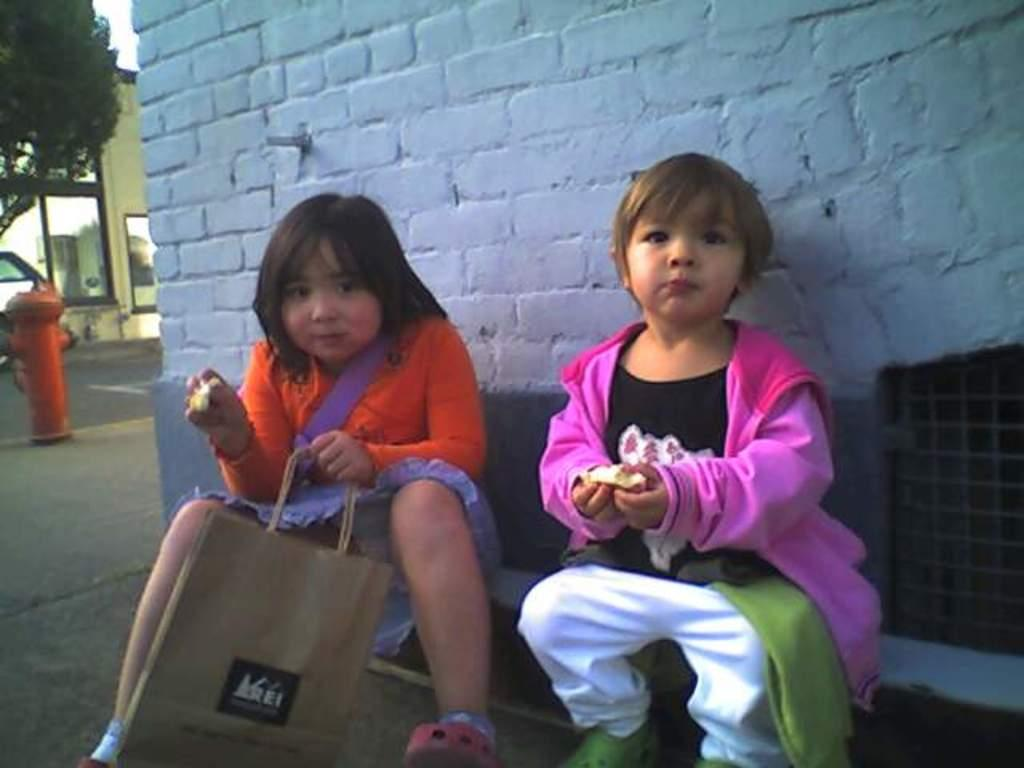How many people are in the image? There are two girls in the picture. What are the girls doing in the image? The girls are sitting and eating something. What can be seen in the background of the picture? There is a wall, trees, and a building in the background of the picture. What is the condition of the sky in the image? The sky is clear in the image. What type of texture can be seen on the beds in the image? There are no beds present in the image, so it is not possible to determine the texture of any bed. 